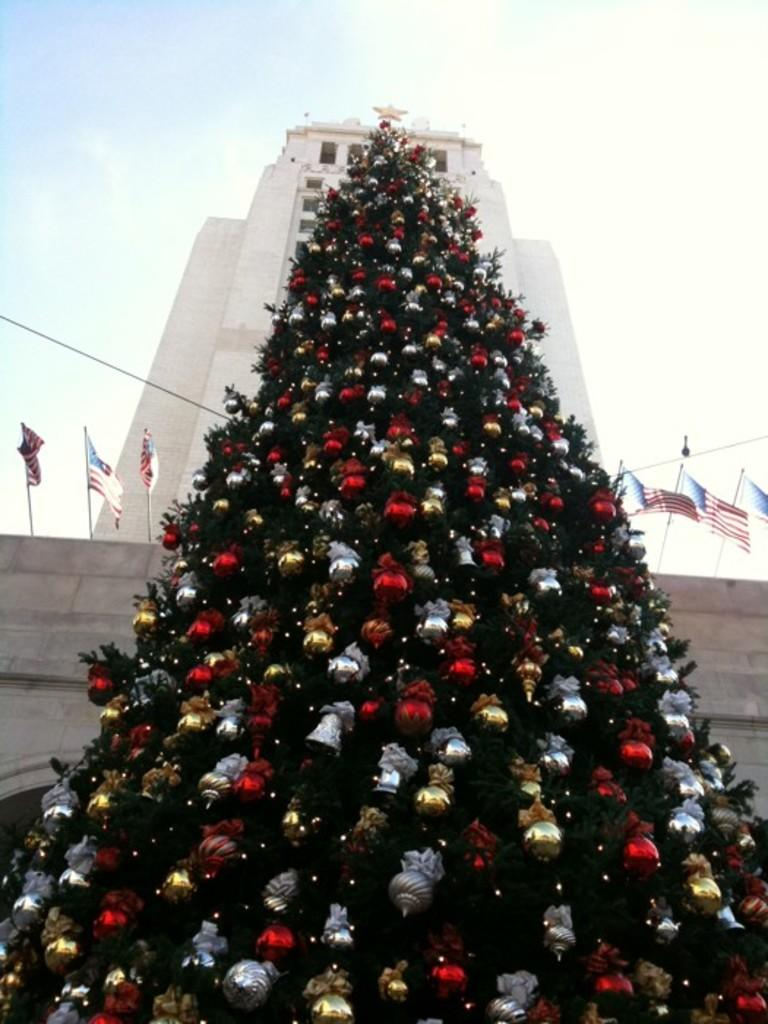What is the main object in the image? There is a Christmas tree in the image. What can be seen behind the Christmas tree? There are flags on a building behind the Christmas tree. What time of day is it in the image, based on the position of the scarecrow? There is no scarecrow present in the image, so we cannot determine the time of day based on its position. 